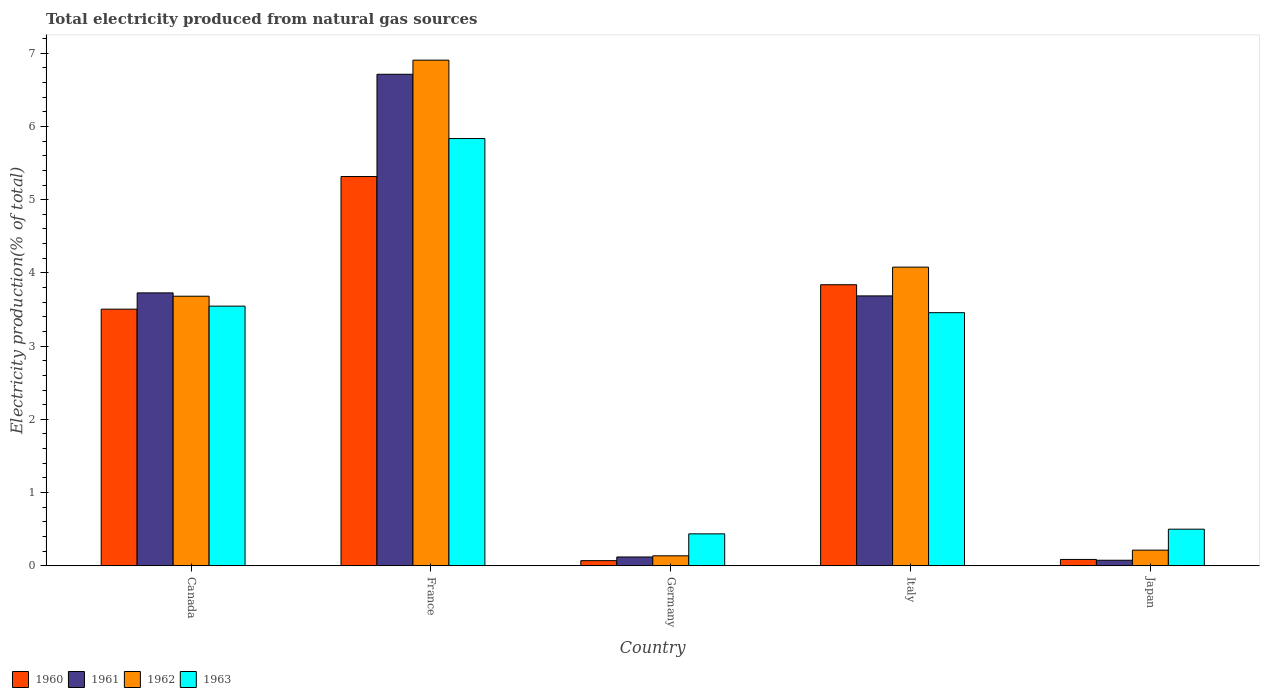How many different coloured bars are there?
Make the answer very short. 4. How many bars are there on the 2nd tick from the left?
Offer a very short reply. 4. What is the total electricity produced in 1960 in Canada?
Give a very brief answer. 3.5. Across all countries, what is the maximum total electricity produced in 1963?
Give a very brief answer. 5.83. Across all countries, what is the minimum total electricity produced in 1961?
Keep it short and to the point. 0.08. In which country was the total electricity produced in 1961 minimum?
Ensure brevity in your answer.  Japan. What is the total total electricity produced in 1960 in the graph?
Offer a very short reply. 12.82. What is the difference between the total electricity produced in 1963 in France and that in Italy?
Make the answer very short. 2.38. What is the difference between the total electricity produced in 1961 in France and the total electricity produced in 1960 in Germany?
Provide a short and direct response. 6.64. What is the average total electricity produced in 1961 per country?
Offer a terse response. 2.86. What is the difference between the total electricity produced of/in 1963 and total electricity produced of/in 1961 in Italy?
Your response must be concise. -0.23. What is the ratio of the total electricity produced in 1960 in France to that in Italy?
Keep it short and to the point. 1.38. Is the difference between the total electricity produced in 1963 in Canada and Italy greater than the difference between the total electricity produced in 1961 in Canada and Italy?
Make the answer very short. Yes. What is the difference between the highest and the second highest total electricity produced in 1962?
Make the answer very short. -0.4. What is the difference between the highest and the lowest total electricity produced in 1962?
Provide a short and direct response. 6.77. Is the sum of the total electricity produced in 1963 in Germany and Italy greater than the maximum total electricity produced in 1962 across all countries?
Ensure brevity in your answer.  No. What does the 1st bar from the left in Germany represents?
Your answer should be compact. 1960. What does the 3rd bar from the right in Japan represents?
Offer a very short reply. 1961. Are all the bars in the graph horizontal?
Make the answer very short. No. Does the graph contain any zero values?
Offer a very short reply. No. Does the graph contain grids?
Keep it short and to the point. No. How are the legend labels stacked?
Give a very brief answer. Horizontal. What is the title of the graph?
Your answer should be compact. Total electricity produced from natural gas sources. What is the label or title of the X-axis?
Your answer should be very brief. Country. What is the label or title of the Y-axis?
Offer a terse response. Electricity production(% of total). What is the Electricity production(% of total) of 1960 in Canada?
Your answer should be very brief. 3.5. What is the Electricity production(% of total) of 1961 in Canada?
Your answer should be compact. 3.73. What is the Electricity production(% of total) of 1962 in Canada?
Make the answer very short. 3.68. What is the Electricity production(% of total) of 1963 in Canada?
Provide a short and direct response. 3.55. What is the Electricity production(% of total) of 1960 in France?
Ensure brevity in your answer.  5.32. What is the Electricity production(% of total) in 1961 in France?
Provide a succinct answer. 6.71. What is the Electricity production(% of total) of 1962 in France?
Offer a terse response. 6.91. What is the Electricity production(% of total) in 1963 in France?
Keep it short and to the point. 5.83. What is the Electricity production(% of total) in 1960 in Germany?
Make the answer very short. 0.07. What is the Electricity production(% of total) in 1961 in Germany?
Offer a very short reply. 0.12. What is the Electricity production(% of total) of 1962 in Germany?
Offer a very short reply. 0.14. What is the Electricity production(% of total) in 1963 in Germany?
Offer a terse response. 0.44. What is the Electricity production(% of total) of 1960 in Italy?
Your answer should be compact. 3.84. What is the Electricity production(% of total) of 1961 in Italy?
Keep it short and to the point. 3.69. What is the Electricity production(% of total) of 1962 in Italy?
Your response must be concise. 4.08. What is the Electricity production(% of total) of 1963 in Italy?
Make the answer very short. 3.46. What is the Electricity production(% of total) in 1960 in Japan?
Offer a very short reply. 0.09. What is the Electricity production(% of total) in 1961 in Japan?
Give a very brief answer. 0.08. What is the Electricity production(% of total) in 1962 in Japan?
Make the answer very short. 0.21. What is the Electricity production(% of total) in 1963 in Japan?
Offer a very short reply. 0.5. Across all countries, what is the maximum Electricity production(% of total) of 1960?
Keep it short and to the point. 5.32. Across all countries, what is the maximum Electricity production(% of total) in 1961?
Provide a short and direct response. 6.71. Across all countries, what is the maximum Electricity production(% of total) in 1962?
Your answer should be compact. 6.91. Across all countries, what is the maximum Electricity production(% of total) of 1963?
Provide a short and direct response. 5.83. Across all countries, what is the minimum Electricity production(% of total) in 1960?
Make the answer very short. 0.07. Across all countries, what is the minimum Electricity production(% of total) of 1961?
Offer a very short reply. 0.08. Across all countries, what is the minimum Electricity production(% of total) of 1962?
Your answer should be compact. 0.14. Across all countries, what is the minimum Electricity production(% of total) of 1963?
Your answer should be compact. 0.44. What is the total Electricity production(% of total) in 1960 in the graph?
Offer a terse response. 12.82. What is the total Electricity production(% of total) of 1961 in the graph?
Your answer should be compact. 14.32. What is the total Electricity production(% of total) of 1962 in the graph?
Offer a very short reply. 15.01. What is the total Electricity production(% of total) in 1963 in the graph?
Give a very brief answer. 13.77. What is the difference between the Electricity production(% of total) of 1960 in Canada and that in France?
Offer a very short reply. -1.81. What is the difference between the Electricity production(% of total) of 1961 in Canada and that in France?
Make the answer very short. -2.99. What is the difference between the Electricity production(% of total) in 1962 in Canada and that in France?
Offer a terse response. -3.22. What is the difference between the Electricity production(% of total) of 1963 in Canada and that in France?
Keep it short and to the point. -2.29. What is the difference between the Electricity production(% of total) of 1960 in Canada and that in Germany?
Give a very brief answer. 3.43. What is the difference between the Electricity production(% of total) in 1961 in Canada and that in Germany?
Keep it short and to the point. 3.61. What is the difference between the Electricity production(% of total) in 1962 in Canada and that in Germany?
Your answer should be very brief. 3.55. What is the difference between the Electricity production(% of total) in 1963 in Canada and that in Germany?
Your response must be concise. 3.11. What is the difference between the Electricity production(% of total) in 1960 in Canada and that in Italy?
Offer a terse response. -0.33. What is the difference between the Electricity production(% of total) in 1961 in Canada and that in Italy?
Make the answer very short. 0.04. What is the difference between the Electricity production(% of total) in 1962 in Canada and that in Italy?
Your answer should be compact. -0.4. What is the difference between the Electricity production(% of total) in 1963 in Canada and that in Italy?
Provide a succinct answer. 0.09. What is the difference between the Electricity production(% of total) in 1960 in Canada and that in Japan?
Provide a succinct answer. 3.42. What is the difference between the Electricity production(% of total) in 1961 in Canada and that in Japan?
Provide a short and direct response. 3.65. What is the difference between the Electricity production(% of total) in 1962 in Canada and that in Japan?
Keep it short and to the point. 3.47. What is the difference between the Electricity production(% of total) of 1963 in Canada and that in Japan?
Offer a very short reply. 3.05. What is the difference between the Electricity production(% of total) in 1960 in France and that in Germany?
Your response must be concise. 5.25. What is the difference between the Electricity production(% of total) of 1961 in France and that in Germany?
Offer a terse response. 6.59. What is the difference between the Electricity production(% of total) in 1962 in France and that in Germany?
Provide a short and direct response. 6.77. What is the difference between the Electricity production(% of total) in 1963 in France and that in Germany?
Provide a short and direct response. 5.4. What is the difference between the Electricity production(% of total) of 1960 in France and that in Italy?
Provide a succinct answer. 1.48. What is the difference between the Electricity production(% of total) in 1961 in France and that in Italy?
Provide a succinct answer. 3.03. What is the difference between the Electricity production(% of total) of 1962 in France and that in Italy?
Your answer should be very brief. 2.83. What is the difference between the Electricity production(% of total) in 1963 in France and that in Italy?
Give a very brief answer. 2.38. What is the difference between the Electricity production(% of total) of 1960 in France and that in Japan?
Make the answer very short. 5.23. What is the difference between the Electricity production(% of total) in 1961 in France and that in Japan?
Ensure brevity in your answer.  6.64. What is the difference between the Electricity production(% of total) of 1962 in France and that in Japan?
Offer a very short reply. 6.69. What is the difference between the Electricity production(% of total) of 1963 in France and that in Japan?
Your response must be concise. 5.33. What is the difference between the Electricity production(% of total) of 1960 in Germany and that in Italy?
Offer a very short reply. -3.77. What is the difference between the Electricity production(% of total) in 1961 in Germany and that in Italy?
Provide a succinct answer. -3.57. What is the difference between the Electricity production(% of total) in 1962 in Germany and that in Italy?
Ensure brevity in your answer.  -3.94. What is the difference between the Electricity production(% of total) in 1963 in Germany and that in Italy?
Your answer should be very brief. -3.02. What is the difference between the Electricity production(% of total) of 1960 in Germany and that in Japan?
Provide a succinct answer. -0.02. What is the difference between the Electricity production(% of total) in 1961 in Germany and that in Japan?
Keep it short and to the point. 0.04. What is the difference between the Electricity production(% of total) in 1962 in Germany and that in Japan?
Your answer should be very brief. -0.08. What is the difference between the Electricity production(% of total) of 1963 in Germany and that in Japan?
Give a very brief answer. -0.06. What is the difference between the Electricity production(% of total) of 1960 in Italy and that in Japan?
Provide a succinct answer. 3.75. What is the difference between the Electricity production(% of total) of 1961 in Italy and that in Japan?
Provide a succinct answer. 3.61. What is the difference between the Electricity production(% of total) in 1962 in Italy and that in Japan?
Offer a very short reply. 3.86. What is the difference between the Electricity production(% of total) in 1963 in Italy and that in Japan?
Make the answer very short. 2.96. What is the difference between the Electricity production(% of total) of 1960 in Canada and the Electricity production(% of total) of 1961 in France?
Offer a very short reply. -3.21. What is the difference between the Electricity production(% of total) of 1960 in Canada and the Electricity production(% of total) of 1962 in France?
Keep it short and to the point. -3.4. What is the difference between the Electricity production(% of total) of 1960 in Canada and the Electricity production(% of total) of 1963 in France?
Your answer should be very brief. -2.33. What is the difference between the Electricity production(% of total) of 1961 in Canada and the Electricity production(% of total) of 1962 in France?
Make the answer very short. -3.18. What is the difference between the Electricity production(% of total) in 1961 in Canada and the Electricity production(% of total) in 1963 in France?
Offer a terse response. -2.11. What is the difference between the Electricity production(% of total) in 1962 in Canada and the Electricity production(% of total) in 1963 in France?
Keep it short and to the point. -2.15. What is the difference between the Electricity production(% of total) in 1960 in Canada and the Electricity production(% of total) in 1961 in Germany?
Provide a succinct answer. 3.38. What is the difference between the Electricity production(% of total) in 1960 in Canada and the Electricity production(% of total) in 1962 in Germany?
Offer a very short reply. 3.37. What is the difference between the Electricity production(% of total) of 1960 in Canada and the Electricity production(% of total) of 1963 in Germany?
Make the answer very short. 3.07. What is the difference between the Electricity production(% of total) in 1961 in Canada and the Electricity production(% of total) in 1962 in Germany?
Offer a terse response. 3.59. What is the difference between the Electricity production(% of total) in 1961 in Canada and the Electricity production(% of total) in 1963 in Germany?
Your response must be concise. 3.29. What is the difference between the Electricity production(% of total) of 1962 in Canada and the Electricity production(% of total) of 1963 in Germany?
Your response must be concise. 3.25. What is the difference between the Electricity production(% of total) in 1960 in Canada and the Electricity production(% of total) in 1961 in Italy?
Give a very brief answer. -0.18. What is the difference between the Electricity production(% of total) of 1960 in Canada and the Electricity production(% of total) of 1962 in Italy?
Give a very brief answer. -0.57. What is the difference between the Electricity production(% of total) of 1960 in Canada and the Electricity production(% of total) of 1963 in Italy?
Your answer should be very brief. 0.05. What is the difference between the Electricity production(% of total) of 1961 in Canada and the Electricity production(% of total) of 1962 in Italy?
Ensure brevity in your answer.  -0.35. What is the difference between the Electricity production(% of total) of 1961 in Canada and the Electricity production(% of total) of 1963 in Italy?
Give a very brief answer. 0.27. What is the difference between the Electricity production(% of total) in 1962 in Canada and the Electricity production(% of total) in 1963 in Italy?
Provide a short and direct response. 0.23. What is the difference between the Electricity production(% of total) in 1960 in Canada and the Electricity production(% of total) in 1961 in Japan?
Ensure brevity in your answer.  3.43. What is the difference between the Electricity production(% of total) in 1960 in Canada and the Electricity production(% of total) in 1962 in Japan?
Your answer should be very brief. 3.29. What is the difference between the Electricity production(% of total) in 1960 in Canada and the Electricity production(% of total) in 1963 in Japan?
Your answer should be compact. 3. What is the difference between the Electricity production(% of total) in 1961 in Canada and the Electricity production(% of total) in 1962 in Japan?
Offer a very short reply. 3.51. What is the difference between the Electricity production(% of total) of 1961 in Canada and the Electricity production(% of total) of 1963 in Japan?
Provide a short and direct response. 3.23. What is the difference between the Electricity production(% of total) of 1962 in Canada and the Electricity production(% of total) of 1963 in Japan?
Offer a terse response. 3.18. What is the difference between the Electricity production(% of total) of 1960 in France and the Electricity production(% of total) of 1961 in Germany?
Provide a short and direct response. 5.2. What is the difference between the Electricity production(% of total) in 1960 in France and the Electricity production(% of total) in 1962 in Germany?
Ensure brevity in your answer.  5.18. What is the difference between the Electricity production(% of total) of 1960 in France and the Electricity production(% of total) of 1963 in Germany?
Offer a terse response. 4.88. What is the difference between the Electricity production(% of total) in 1961 in France and the Electricity production(% of total) in 1962 in Germany?
Make the answer very short. 6.58. What is the difference between the Electricity production(% of total) in 1961 in France and the Electricity production(% of total) in 1963 in Germany?
Provide a succinct answer. 6.28. What is the difference between the Electricity production(% of total) of 1962 in France and the Electricity production(% of total) of 1963 in Germany?
Your response must be concise. 6.47. What is the difference between the Electricity production(% of total) of 1960 in France and the Electricity production(% of total) of 1961 in Italy?
Your answer should be very brief. 1.63. What is the difference between the Electricity production(% of total) in 1960 in France and the Electricity production(% of total) in 1962 in Italy?
Offer a very short reply. 1.24. What is the difference between the Electricity production(% of total) of 1960 in France and the Electricity production(% of total) of 1963 in Italy?
Give a very brief answer. 1.86. What is the difference between the Electricity production(% of total) of 1961 in France and the Electricity production(% of total) of 1962 in Italy?
Your answer should be compact. 2.63. What is the difference between the Electricity production(% of total) of 1961 in France and the Electricity production(% of total) of 1963 in Italy?
Your response must be concise. 3.26. What is the difference between the Electricity production(% of total) of 1962 in France and the Electricity production(% of total) of 1963 in Italy?
Ensure brevity in your answer.  3.45. What is the difference between the Electricity production(% of total) in 1960 in France and the Electricity production(% of total) in 1961 in Japan?
Your answer should be compact. 5.24. What is the difference between the Electricity production(% of total) of 1960 in France and the Electricity production(% of total) of 1962 in Japan?
Provide a succinct answer. 5.1. What is the difference between the Electricity production(% of total) of 1960 in France and the Electricity production(% of total) of 1963 in Japan?
Your answer should be very brief. 4.82. What is the difference between the Electricity production(% of total) in 1961 in France and the Electricity production(% of total) in 1962 in Japan?
Your response must be concise. 6.5. What is the difference between the Electricity production(% of total) in 1961 in France and the Electricity production(% of total) in 1963 in Japan?
Give a very brief answer. 6.21. What is the difference between the Electricity production(% of total) of 1962 in France and the Electricity production(% of total) of 1963 in Japan?
Make the answer very short. 6.4. What is the difference between the Electricity production(% of total) in 1960 in Germany and the Electricity production(% of total) in 1961 in Italy?
Your answer should be very brief. -3.62. What is the difference between the Electricity production(% of total) of 1960 in Germany and the Electricity production(% of total) of 1962 in Italy?
Your answer should be compact. -4.01. What is the difference between the Electricity production(% of total) of 1960 in Germany and the Electricity production(% of total) of 1963 in Italy?
Your response must be concise. -3.39. What is the difference between the Electricity production(% of total) of 1961 in Germany and the Electricity production(% of total) of 1962 in Italy?
Your answer should be compact. -3.96. What is the difference between the Electricity production(% of total) in 1961 in Germany and the Electricity production(% of total) in 1963 in Italy?
Make the answer very short. -3.34. What is the difference between the Electricity production(% of total) in 1962 in Germany and the Electricity production(% of total) in 1963 in Italy?
Offer a terse response. -3.32. What is the difference between the Electricity production(% of total) in 1960 in Germany and the Electricity production(% of total) in 1961 in Japan?
Offer a very short reply. -0.01. What is the difference between the Electricity production(% of total) of 1960 in Germany and the Electricity production(% of total) of 1962 in Japan?
Offer a terse response. -0.14. What is the difference between the Electricity production(% of total) in 1960 in Germany and the Electricity production(% of total) in 1963 in Japan?
Your response must be concise. -0.43. What is the difference between the Electricity production(% of total) in 1961 in Germany and the Electricity production(% of total) in 1962 in Japan?
Your response must be concise. -0.09. What is the difference between the Electricity production(% of total) of 1961 in Germany and the Electricity production(% of total) of 1963 in Japan?
Provide a short and direct response. -0.38. What is the difference between the Electricity production(% of total) of 1962 in Germany and the Electricity production(% of total) of 1963 in Japan?
Your answer should be compact. -0.36. What is the difference between the Electricity production(% of total) of 1960 in Italy and the Electricity production(% of total) of 1961 in Japan?
Your answer should be compact. 3.76. What is the difference between the Electricity production(% of total) in 1960 in Italy and the Electricity production(% of total) in 1962 in Japan?
Make the answer very short. 3.62. What is the difference between the Electricity production(% of total) in 1960 in Italy and the Electricity production(% of total) in 1963 in Japan?
Offer a very short reply. 3.34. What is the difference between the Electricity production(% of total) of 1961 in Italy and the Electricity production(% of total) of 1962 in Japan?
Your answer should be compact. 3.47. What is the difference between the Electricity production(% of total) of 1961 in Italy and the Electricity production(% of total) of 1963 in Japan?
Give a very brief answer. 3.19. What is the difference between the Electricity production(% of total) in 1962 in Italy and the Electricity production(% of total) in 1963 in Japan?
Ensure brevity in your answer.  3.58. What is the average Electricity production(% of total) of 1960 per country?
Keep it short and to the point. 2.56. What is the average Electricity production(% of total) in 1961 per country?
Provide a short and direct response. 2.86. What is the average Electricity production(% of total) in 1962 per country?
Offer a terse response. 3. What is the average Electricity production(% of total) in 1963 per country?
Your answer should be compact. 2.75. What is the difference between the Electricity production(% of total) in 1960 and Electricity production(% of total) in 1961 in Canada?
Keep it short and to the point. -0.22. What is the difference between the Electricity production(% of total) in 1960 and Electricity production(% of total) in 1962 in Canada?
Provide a succinct answer. -0.18. What is the difference between the Electricity production(% of total) of 1960 and Electricity production(% of total) of 1963 in Canada?
Offer a very short reply. -0.04. What is the difference between the Electricity production(% of total) in 1961 and Electricity production(% of total) in 1962 in Canada?
Ensure brevity in your answer.  0.05. What is the difference between the Electricity production(% of total) in 1961 and Electricity production(% of total) in 1963 in Canada?
Keep it short and to the point. 0.18. What is the difference between the Electricity production(% of total) of 1962 and Electricity production(% of total) of 1963 in Canada?
Give a very brief answer. 0.14. What is the difference between the Electricity production(% of total) in 1960 and Electricity production(% of total) in 1961 in France?
Your answer should be compact. -1.4. What is the difference between the Electricity production(% of total) of 1960 and Electricity production(% of total) of 1962 in France?
Provide a short and direct response. -1.59. What is the difference between the Electricity production(% of total) of 1960 and Electricity production(% of total) of 1963 in France?
Make the answer very short. -0.52. What is the difference between the Electricity production(% of total) of 1961 and Electricity production(% of total) of 1962 in France?
Offer a very short reply. -0.19. What is the difference between the Electricity production(% of total) of 1961 and Electricity production(% of total) of 1963 in France?
Keep it short and to the point. 0.88. What is the difference between the Electricity production(% of total) of 1962 and Electricity production(% of total) of 1963 in France?
Your answer should be compact. 1.07. What is the difference between the Electricity production(% of total) in 1960 and Electricity production(% of total) in 1962 in Germany?
Make the answer very short. -0.07. What is the difference between the Electricity production(% of total) of 1960 and Electricity production(% of total) of 1963 in Germany?
Make the answer very short. -0.37. What is the difference between the Electricity production(% of total) in 1961 and Electricity production(% of total) in 1962 in Germany?
Keep it short and to the point. -0.02. What is the difference between the Electricity production(% of total) of 1961 and Electricity production(% of total) of 1963 in Germany?
Provide a short and direct response. -0.32. What is the difference between the Electricity production(% of total) in 1962 and Electricity production(% of total) in 1963 in Germany?
Your answer should be very brief. -0.3. What is the difference between the Electricity production(% of total) of 1960 and Electricity production(% of total) of 1961 in Italy?
Provide a short and direct response. 0.15. What is the difference between the Electricity production(% of total) in 1960 and Electricity production(% of total) in 1962 in Italy?
Provide a short and direct response. -0.24. What is the difference between the Electricity production(% of total) in 1960 and Electricity production(% of total) in 1963 in Italy?
Ensure brevity in your answer.  0.38. What is the difference between the Electricity production(% of total) in 1961 and Electricity production(% of total) in 1962 in Italy?
Your answer should be very brief. -0.39. What is the difference between the Electricity production(% of total) of 1961 and Electricity production(% of total) of 1963 in Italy?
Give a very brief answer. 0.23. What is the difference between the Electricity production(% of total) in 1962 and Electricity production(% of total) in 1963 in Italy?
Your answer should be compact. 0.62. What is the difference between the Electricity production(% of total) in 1960 and Electricity production(% of total) in 1961 in Japan?
Provide a short and direct response. 0.01. What is the difference between the Electricity production(% of total) in 1960 and Electricity production(% of total) in 1962 in Japan?
Offer a terse response. -0.13. What is the difference between the Electricity production(% of total) of 1960 and Electricity production(% of total) of 1963 in Japan?
Offer a terse response. -0.41. What is the difference between the Electricity production(% of total) in 1961 and Electricity production(% of total) in 1962 in Japan?
Offer a terse response. -0.14. What is the difference between the Electricity production(% of total) of 1961 and Electricity production(% of total) of 1963 in Japan?
Make the answer very short. -0.42. What is the difference between the Electricity production(% of total) in 1962 and Electricity production(% of total) in 1963 in Japan?
Offer a very short reply. -0.29. What is the ratio of the Electricity production(% of total) of 1960 in Canada to that in France?
Offer a very short reply. 0.66. What is the ratio of the Electricity production(% of total) of 1961 in Canada to that in France?
Give a very brief answer. 0.56. What is the ratio of the Electricity production(% of total) in 1962 in Canada to that in France?
Keep it short and to the point. 0.53. What is the ratio of the Electricity production(% of total) of 1963 in Canada to that in France?
Give a very brief answer. 0.61. What is the ratio of the Electricity production(% of total) in 1960 in Canada to that in Germany?
Offer a very short reply. 49.85. What is the ratio of the Electricity production(% of total) of 1961 in Canada to that in Germany?
Your response must be concise. 30.98. What is the ratio of the Electricity production(% of total) in 1962 in Canada to that in Germany?
Provide a succinct answer. 27.02. What is the ratio of the Electricity production(% of total) of 1963 in Canada to that in Germany?
Keep it short and to the point. 8.13. What is the ratio of the Electricity production(% of total) of 1960 in Canada to that in Italy?
Keep it short and to the point. 0.91. What is the ratio of the Electricity production(% of total) in 1961 in Canada to that in Italy?
Ensure brevity in your answer.  1.01. What is the ratio of the Electricity production(% of total) of 1962 in Canada to that in Italy?
Provide a short and direct response. 0.9. What is the ratio of the Electricity production(% of total) in 1963 in Canada to that in Italy?
Your answer should be very brief. 1.03. What is the ratio of the Electricity production(% of total) in 1960 in Canada to that in Japan?
Keep it short and to the point. 40.48. What is the ratio of the Electricity production(% of total) of 1961 in Canada to that in Japan?
Your answer should be compact. 49.23. What is the ratio of the Electricity production(% of total) of 1962 in Canada to that in Japan?
Your answer should be very brief. 17.23. What is the ratio of the Electricity production(% of total) of 1963 in Canada to that in Japan?
Offer a terse response. 7.09. What is the ratio of the Electricity production(% of total) in 1960 in France to that in Germany?
Provide a short and direct response. 75.62. What is the ratio of the Electricity production(% of total) of 1961 in France to that in Germany?
Your answer should be very brief. 55.79. What is the ratio of the Electricity production(% of total) in 1962 in France to that in Germany?
Make the answer very short. 50.69. What is the ratio of the Electricity production(% of total) of 1963 in France to that in Germany?
Provide a succinct answer. 13.38. What is the ratio of the Electricity production(% of total) of 1960 in France to that in Italy?
Your response must be concise. 1.39. What is the ratio of the Electricity production(% of total) of 1961 in France to that in Italy?
Offer a very short reply. 1.82. What is the ratio of the Electricity production(% of total) of 1962 in France to that in Italy?
Your answer should be compact. 1.69. What is the ratio of the Electricity production(% of total) in 1963 in France to that in Italy?
Make the answer very short. 1.69. What is the ratio of the Electricity production(% of total) in 1960 in France to that in Japan?
Ensure brevity in your answer.  61.4. What is the ratio of the Electricity production(% of total) in 1961 in France to that in Japan?
Make the answer very short. 88.67. What is the ratio of the Electricity production(% of total) of 1962 in France to that in Japan?
Make the answer very short. 32.32. What is the ratio of the Electricity production(% of total) of 1963 in France to that in Japan?
Make the answer very short. 11.67. What is the ratio of the Electricity production(% of total) of 1960 in Germany to that in Italy?
Provide a short and direct response. 0.02. What is the ratio of the Electricity production(% of total) in 1961 in Germany to that in Italy?
Your answer should be compact. 0.03. What is the ratio of the Electricity production(% of total) of 1962 in Germany to that in Italy?
Make the answer very short. 0.03. What is the ratio of the Electricity production(% of total) of 1963 in Germany to that in Italy?
Your response must be concise. 0.13. What is the ratio of the Electricity production(% of total) of 1960 in Germany to that in Japan?
Make the answer very short. 0.81. What is the ratio of the Electricity production(% of total) in 1961 in Germany to that in Japan?
Offer a very short reply. 1.59. What is the ratio of the Electricity production(% of total) of 1962 in Germany to that in Japan?
Your answer should be very brief. 0.64. What is the ratio of the Electricity production(% of total) of 1963 in Germany to that in Japan?
Keep it short and to the point. 0.87. What is the ratio of the Electricity production(% of total) in 1960 in Italy to that in Japan?
Keep it short and to the point. 44.33. What is the ratio of the Electricity production(% of total) in 1961 in Italy to that in Japan?
Keep it short and to the point. 48.69. What is the ratio of the Electricity production(% of total) in 1962 in Italy to that in Japan?
Ensure brevity in your answer.  19.09. What is the ratio of the Electricity production(% of total) in 1963 in Italy to that in Japan?
Make the answer very short. 6.91. What is the difference between the highest and the second highest Electricity production(% of total) of 1960?
Your answer should be very brief. 1.48. What is the difference between the highest and the second highest Electricity production(% of total) of 1961?
Provide a short and direct response. 2.99. What is the difference between the highest and the second highest Electricity production(% of total) of 1962?
Your response must be concise. 2.83. What is the difference between the highest and the second highest Electricity production(% of total) of 1963?
Offer a very short reply. 2.29. What is the difference between the highest and the lowest Electricity production(% of total) of 1960?
Keep it short and to the point. 5.25. What is the difference between the highest and the lowest Electricity production(% of total) in 1961?
Provide a succinct answer. 6.64. What is the difference between the highest and the lowest Electricity production(% of total) of 1962?
Provide a succinct answer. 6.77. What is the difference between the highest and the lowest Electricity production(% of total) in 1963?
Give a very brief answer. 5.4. 